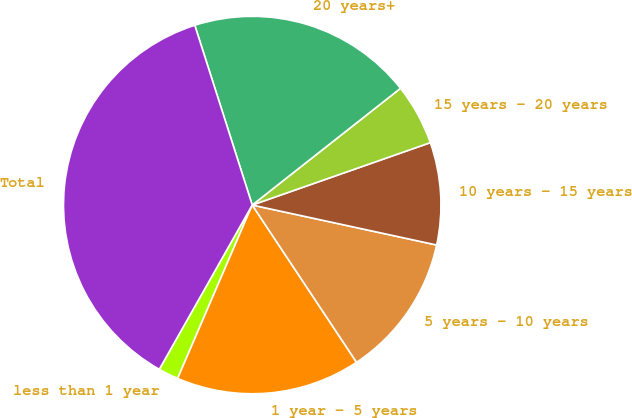<chart> <loc_0><loc_0><loc_500><loc_500><pie_chart><fcel>less than 1 year<fcel>1 year - 5 years<fcel>5 years - 10 years<fcel>10 years - 15 years<fcel>15 years - 20 years<fcel>20 years+<fcel>Total<nl><fcel>1.73%<fcel>15.79%<fcel>12.28%<fcel>8.76%<fcel>5.25%<fcel>19.31%<fcel>36.88%<nl></chart> 